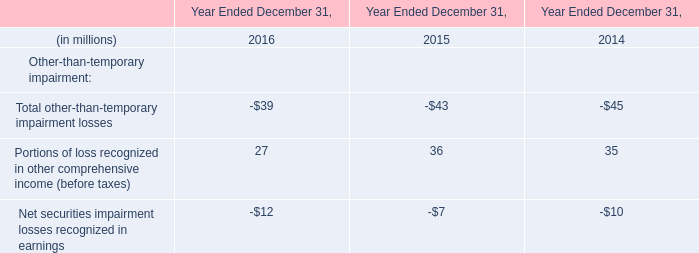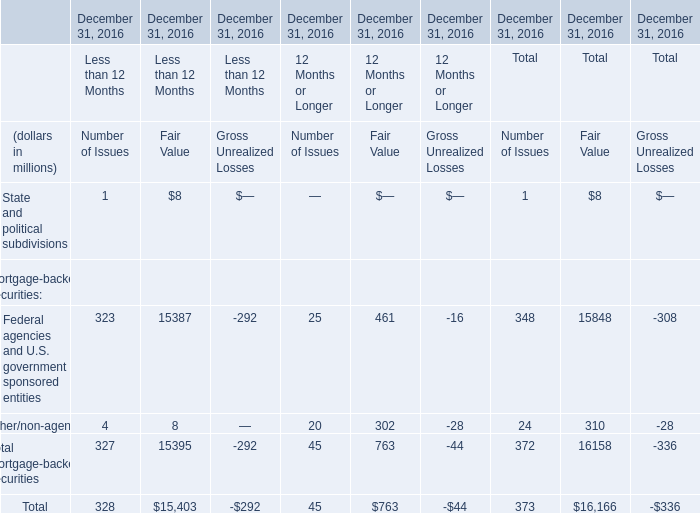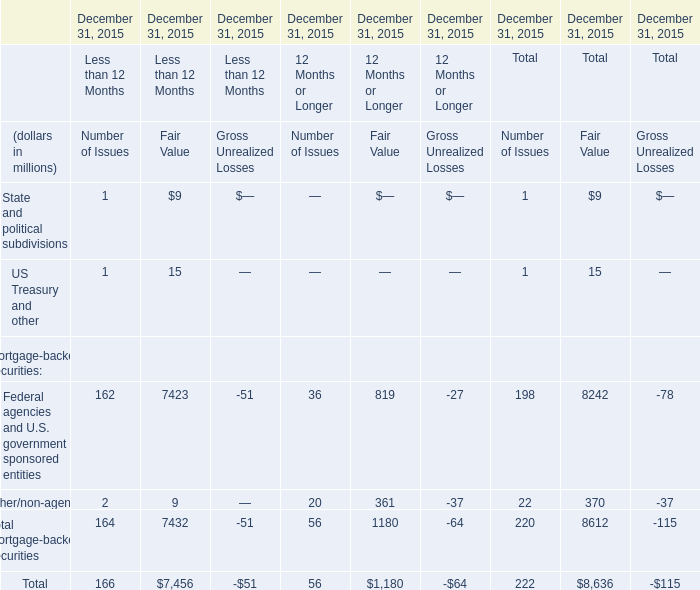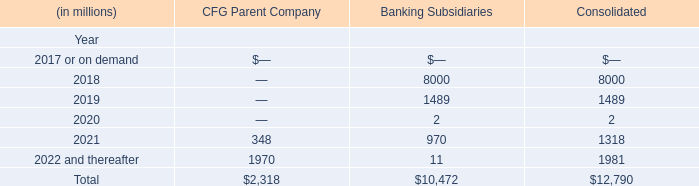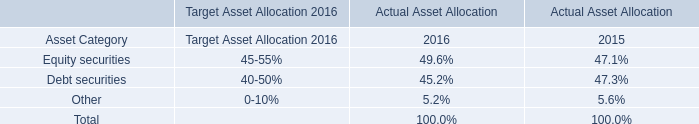What is the proportion of all Number of Issues that are greater than 0 to the total amount of Number of Issues, in 2015 for Less than 12 Months? 
Computations: (166 / 166)
Answer: 1.0. 